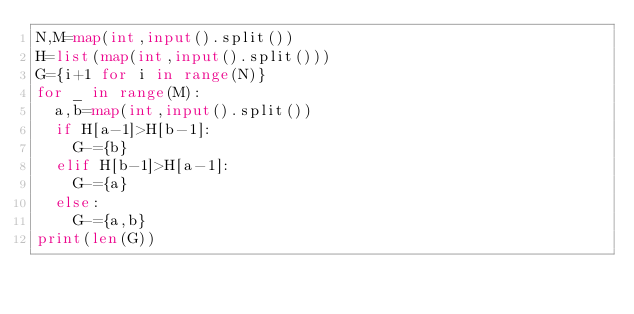<code> <loc_0><loc_0><loc_500><loc_500><_Python_>N,M=map(int,input().split())
H=list(map(int,input().split()))
G={i+1 for i in range(N)}
for _ in range(M):
  a,b=map(int,input().split())
  if H[a-1]>H[b-1]:
    G-={b}
  elif H[b-1]>H[a-1]:
    G-={a}
  else:
    G-={a,b}
print(len(G))</code> 